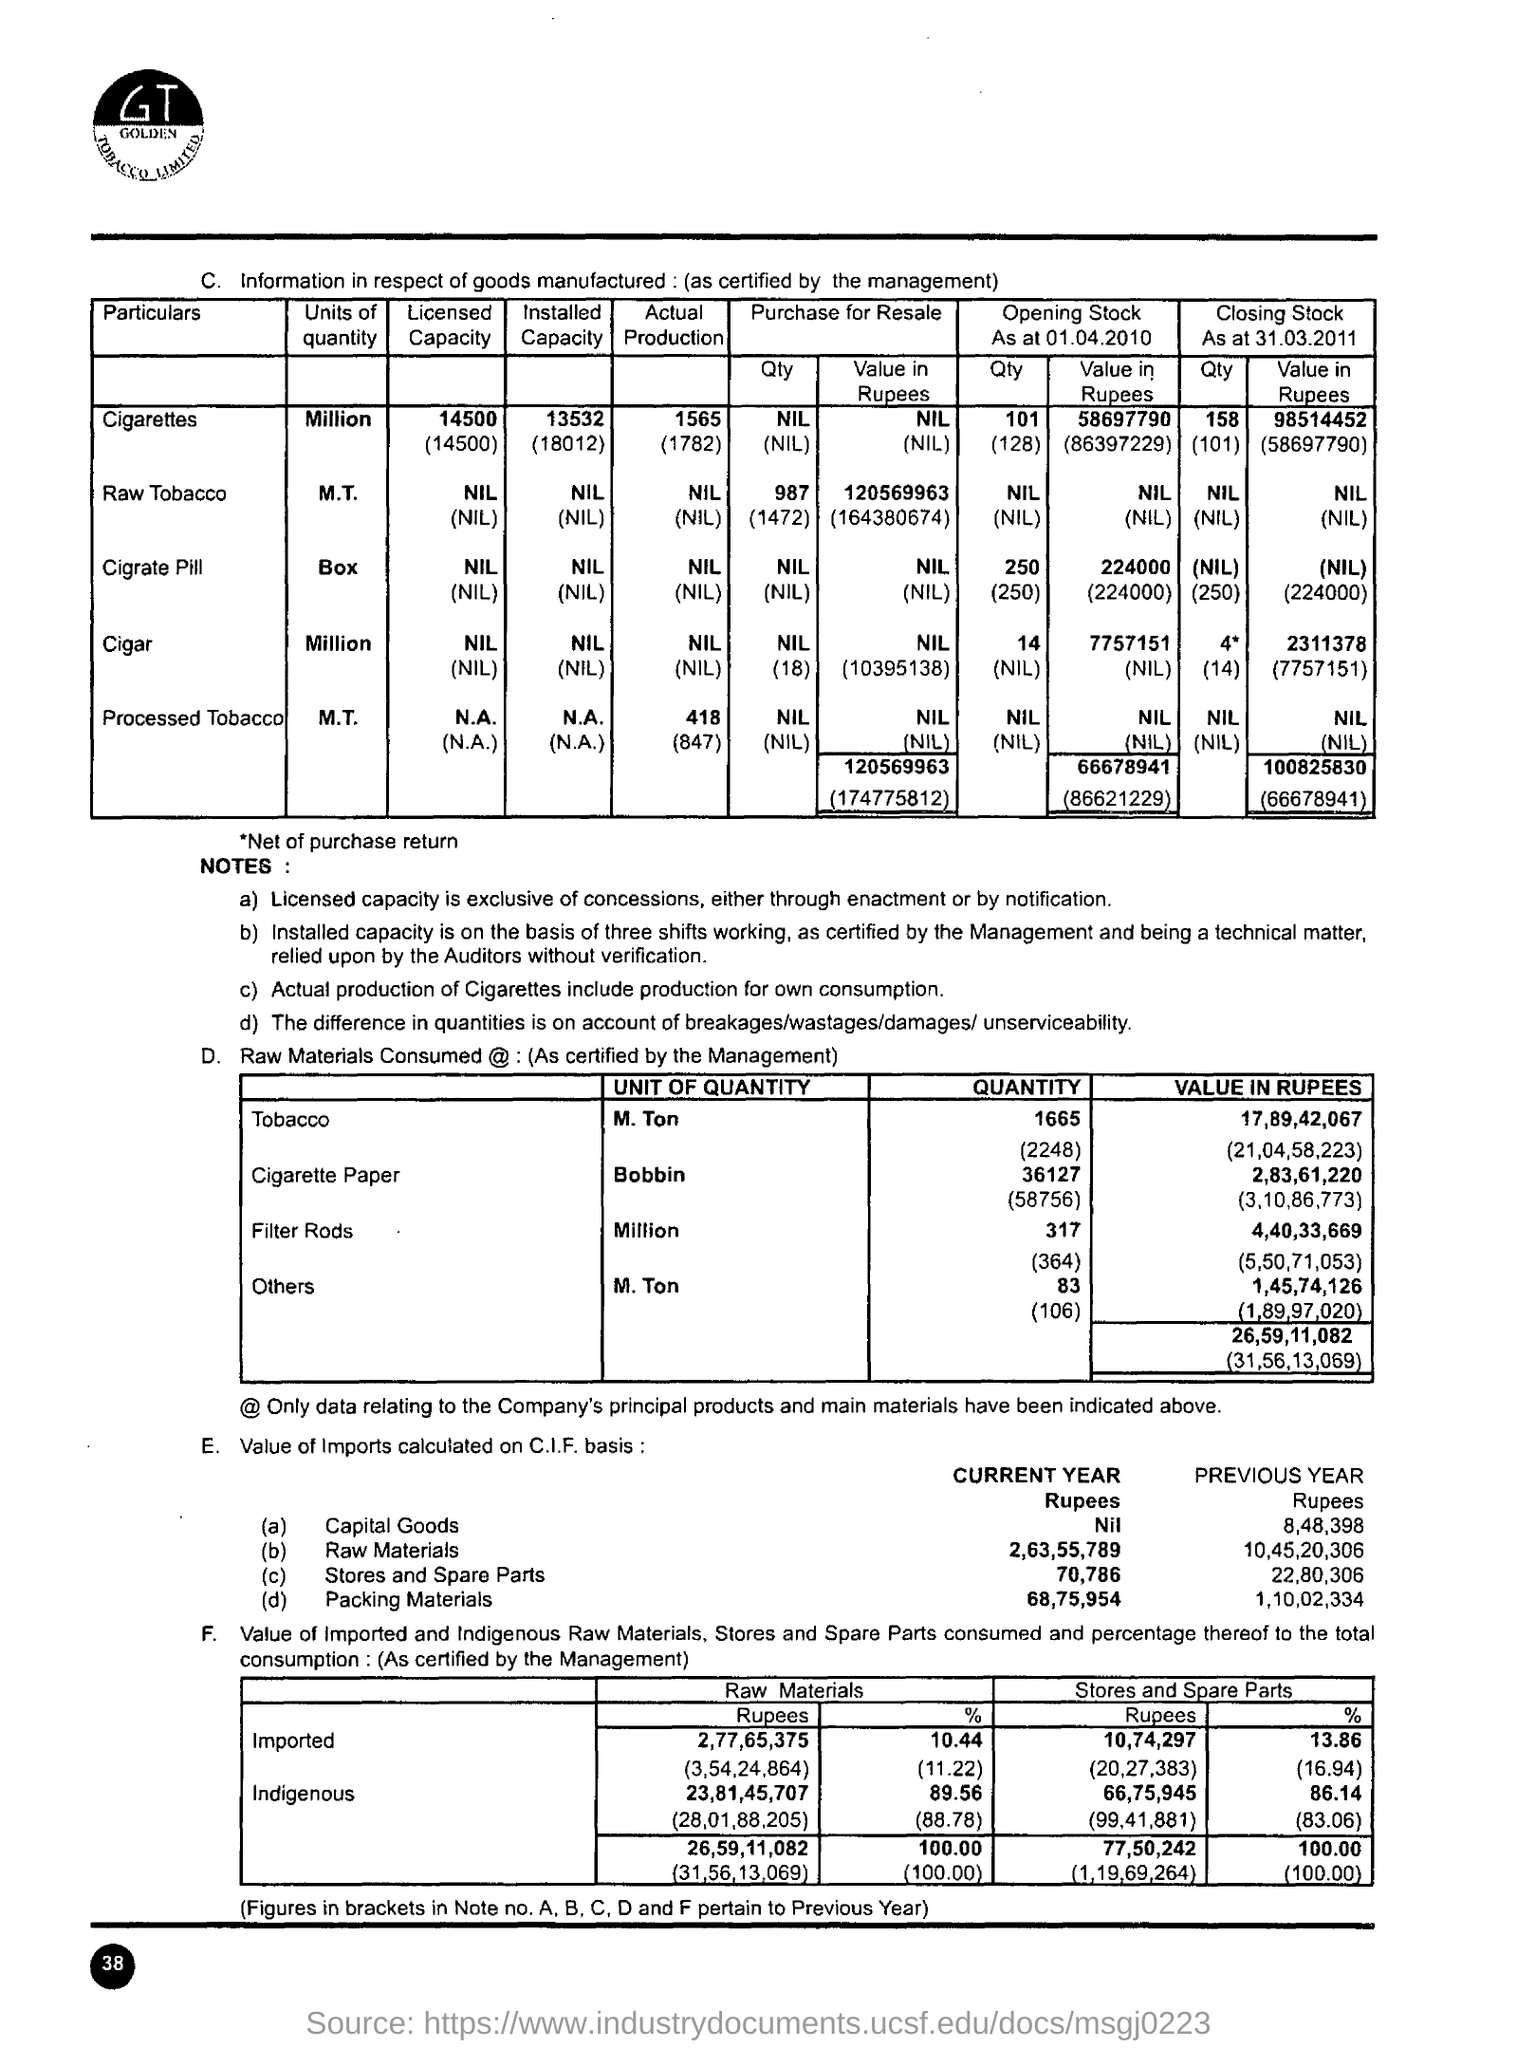What is the Page Number?
Provide a short and direct response. 38. What is the value of tobacco in rupees?
Provide a short and direct response. 17,89,42,067 (21,04,58,223). What is the value of imports of raw materials calculated on the C.I.F basis in the current year?
Your answer should be very brief. 2,63,55,789. What is the value of imports of packing materials calculated on the C.I.F basis in the current year?
Provide a succinct answer. 68,75,954. What is the value of imports of stores and spare parts calculated on the C.I.F basis in the previous year?
Ensure brevity in your answer.  22,80,306. 